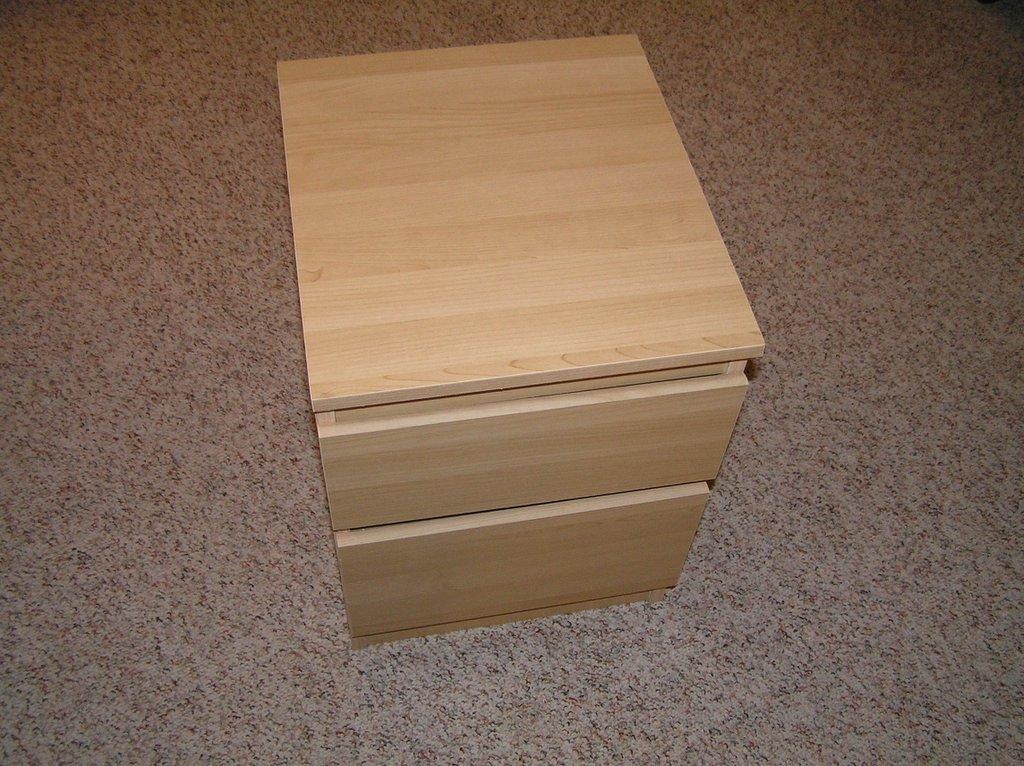What is placed on the floor in the image? There is a box with drawers on the floor. Can you describe the box on the floor? The box has drawers, which suggests it might be used for storage or organization. What type of work is being discussed in the meeting taking place in the image? There is no meeting or discussion of work present in the image; it only features a box with drawers on the floor. How many planes can be seen flying in the image? There are no planes visible in the image. 